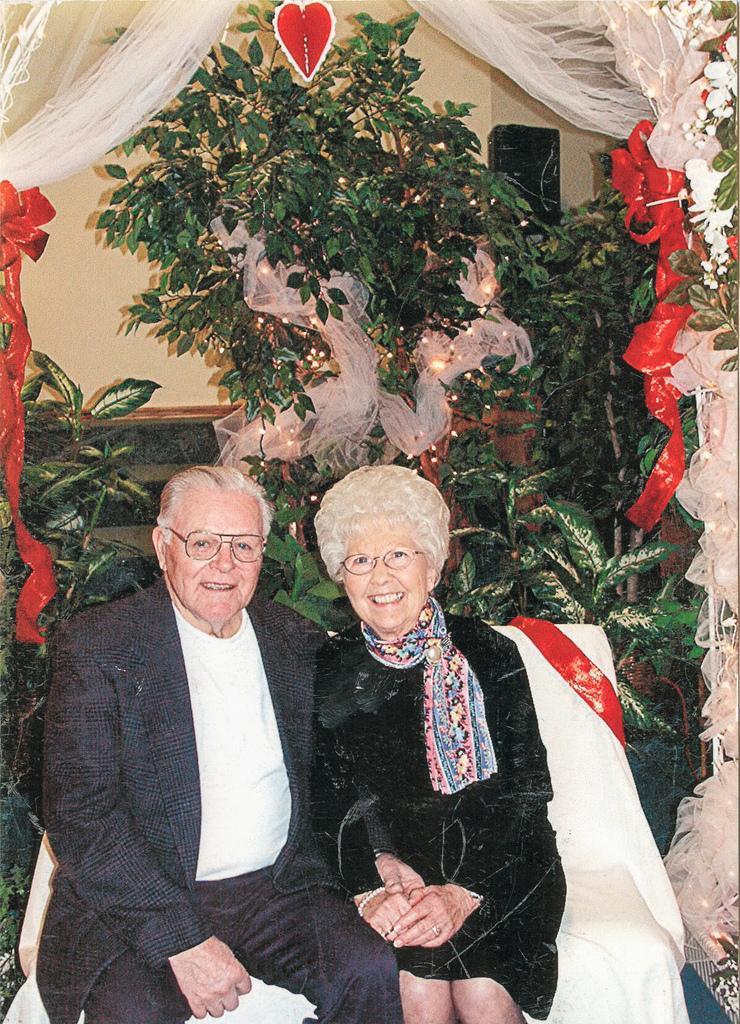Could you give a brief overview of what you see in this image? In the center of the image there are two people sitting on chairs. In the background of the image there are plants. There is a wall. At the top of the image there is a white color curtain. 